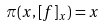Convert formula to latex. <formula><loc_0><loc_0><loc_500><loc_500>\pi ( x , [ f ] _ { x } ) = x</formula> 